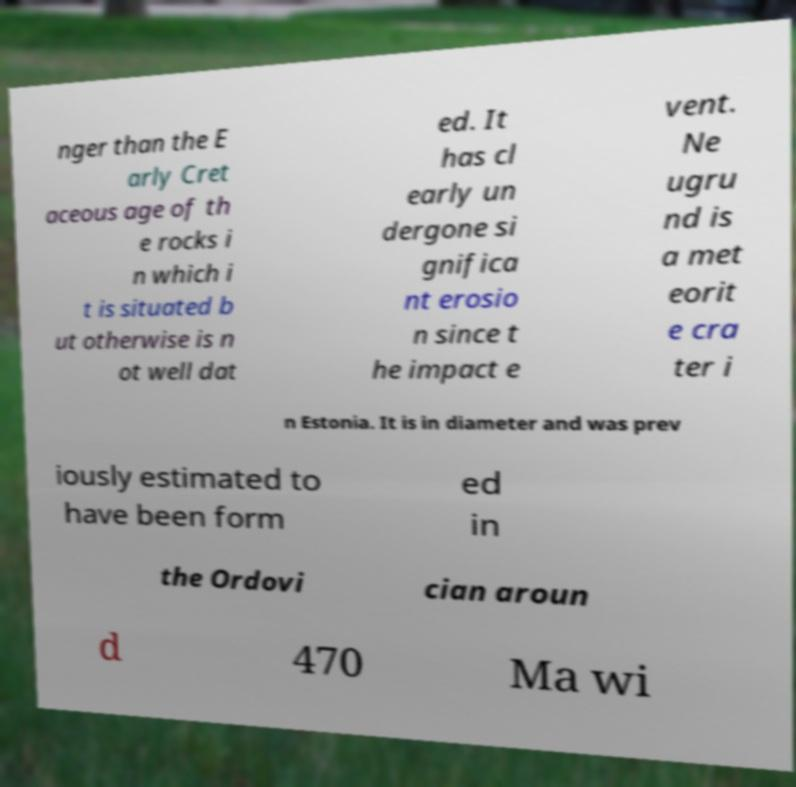There's text embedded in this image that I need extracted. Can you transcribe it verbatim? nger than the E arly Cret aceous age of th e rocks i n which i t is situated b ut otherwise is n ot well dat ed. It has cl early un dergone si gnifica nt erosio n since t he impact e vent. Ne ugru nd is a met eorit e cra ter i n Estonia. It is in diameter and was prev iously estimated to have been form ed in the Ordovi cian aroun d 470 Ma wi 